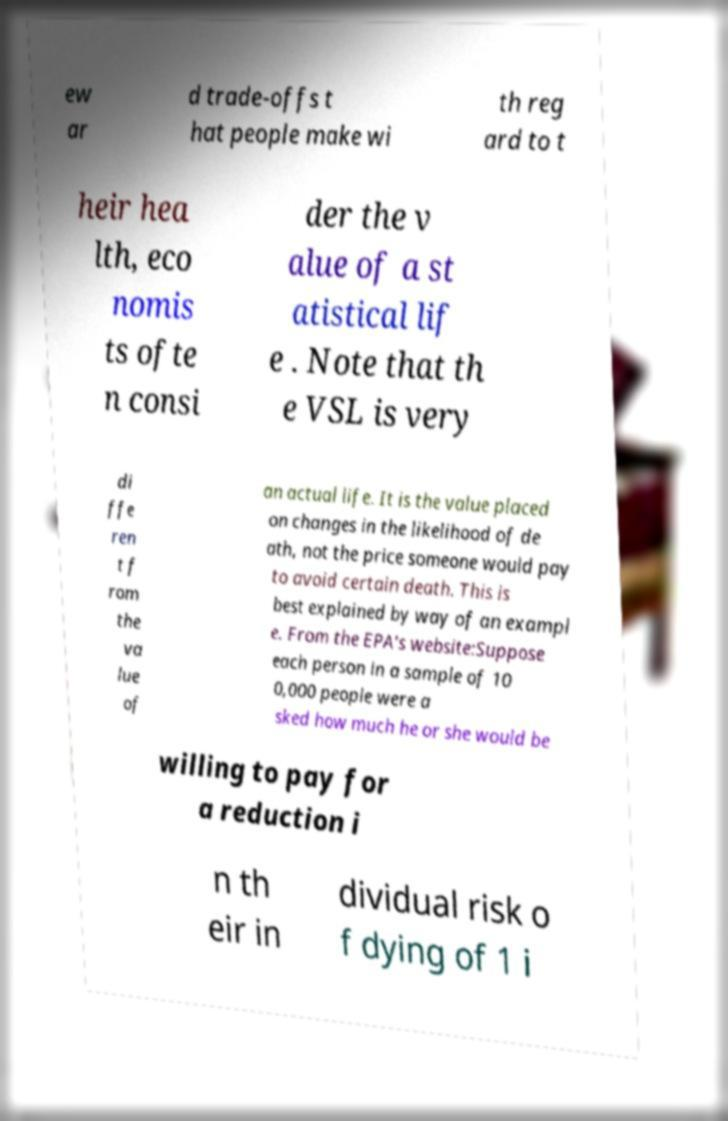There's text embedded in this image that I need extracted. Can you transcribe it verbatim? ew ar d trade-offs t hat people make wi th reg ard to t heir hea lth, eco nomis ts ofte n consi der the v alue of a st atistical lif e . Note that th e VSL is very di ffe ren t f rom the va lue of an actual life. It is the value placed on changes in the likelihood of de ath, not the price someone would pay to avoid certain death. This is best explained by way of an exampl e. From the EPA's website:Suppose each person in a sample of 10 0,000 people were a sked how much he or she would be willing to pay for a reduction i n th eir in dividual risk o f dying of 1 i 